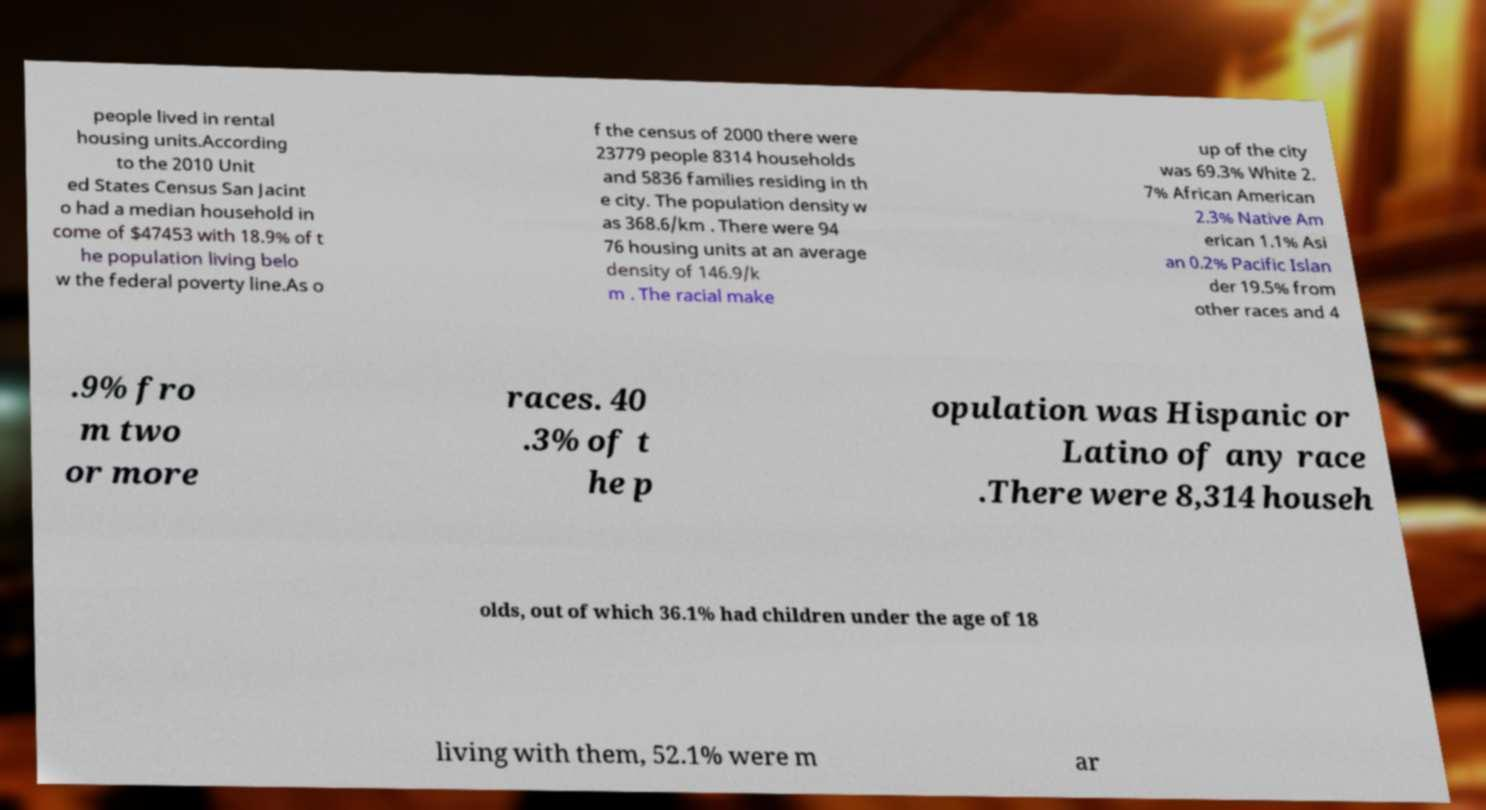Please read and relay the text visible in this image. What does it say? people lived in rental housing units.According to the 2010 Unit ed States Census San Jacint o had a median household in come of $47453 with 18.9% of t he population living belo w the federal poverty line.As o f the census of 2000 there were 23779 people 8314 households and 5836 families residing in th e city. The population density w as 368.6/km . There were 94 76 housing units at an average density of 146.9/k m . The racial make up of the city was 69.3% White 2. 7% African American 2.3% Native Am erican 1.1% Asi an 0.2% Pacific Islan der 19.5% from other races and 4 .9% fro m two or more races. 40 .3% of t he p opulation was Hispanic or Latino of any race .There were 8,314 househ olds, out of which 36.1% had children under the age of 18 living with them, 52.1% were m ar 